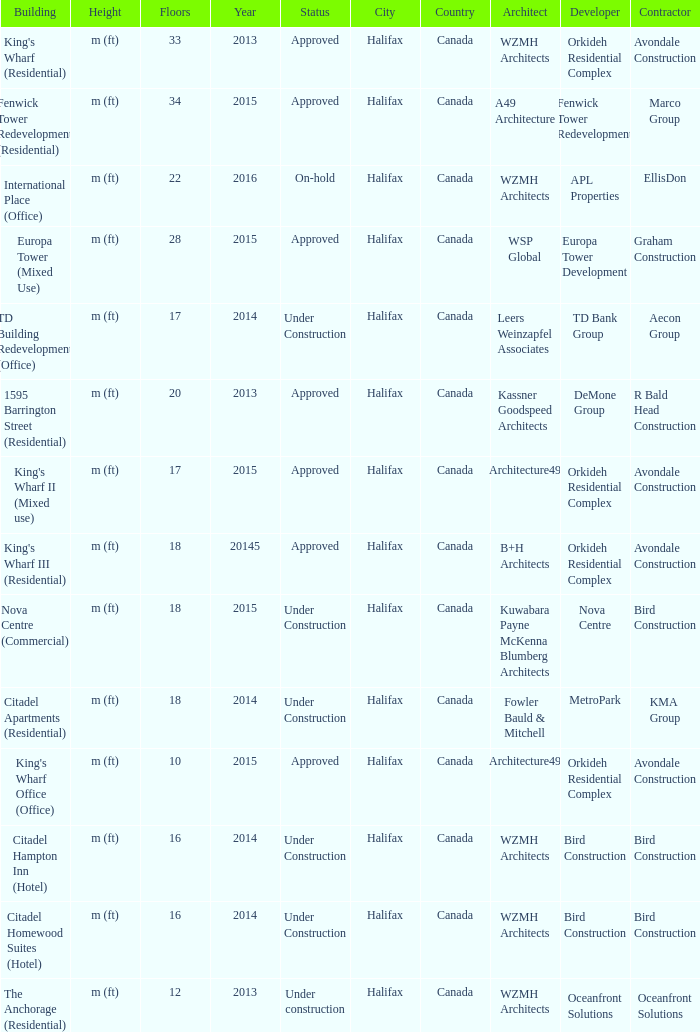What construction features 2013 and comprises above 20 floors? King's Wharf (Residential). 